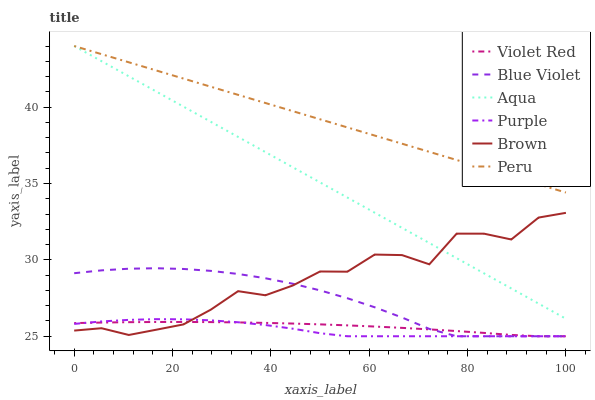Does Purple have the minimum area under the curve?
Answer yes or no. Yes. Does Peru have the maximum area under the curve?
Answer yes or no. Yes. Does Violet Red have the minimum area under the curve?
Answer yes or no. No. Does Violet Red have the maximum area under the curve?
Answer yes or no. No. Is Aqua the smoothest?
Answer yes or no. Yes. Is Brown the roughest?
Answer yes or no. Yes. Is Violet Red the smoothest?
Answer yes or no. No. Is Violet Red the roughest?
Answer yes or no. No. Does Violet Red have the lowest value?
Answer yes or no. Yes. Does Aqua have the lowest value?
Answer yes or no. No. Does Peru have the highest value?
Answer yes or no. Yes. Does Purple have the highest value?
Answer yes or no. No. Is Brown less than Peru?
Answer yes or no. Yes. Is Aqua greater than Blue Violet?
Answer yes or no. Yes. Does Peru intersect Aqua?
Answer yes or no. Yes. Is Peru less than Aqua?
Answer yes or no. No. Is Peru greater than Aqua?
Answer yes or no. No. Does Brown intersect Peru?
Answer yes or no. No. 